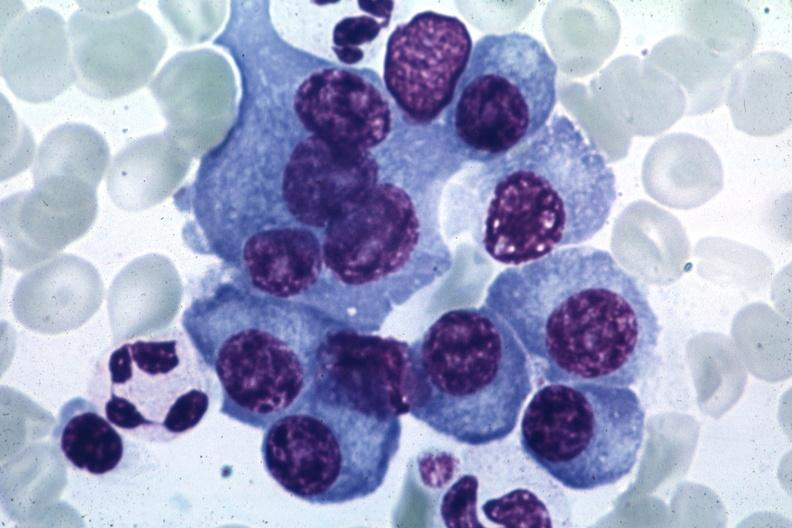what is present?
Answer the question using a single word or phrase. Hematologic 